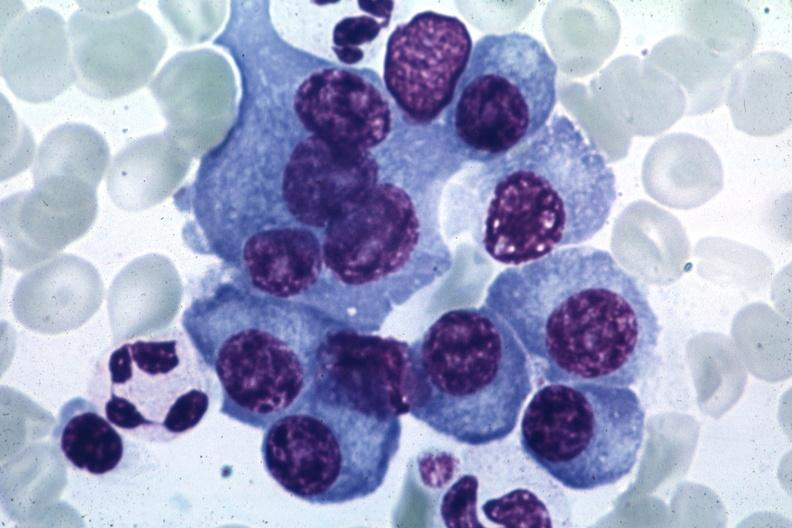what is present?
Answer the question using a single word or phrase. Hematologic 